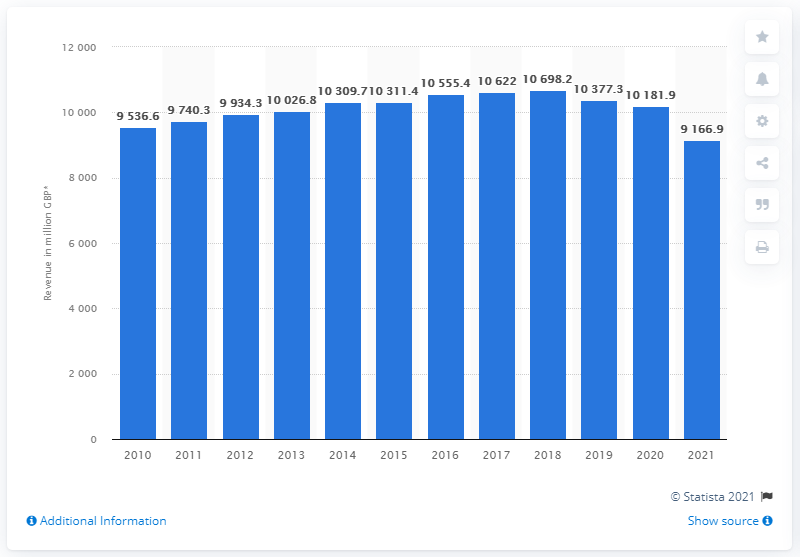Point out several critical features in this image. In the year ending April 3, 2021, Marks and Spencer generated a total revenue of 91,669. 